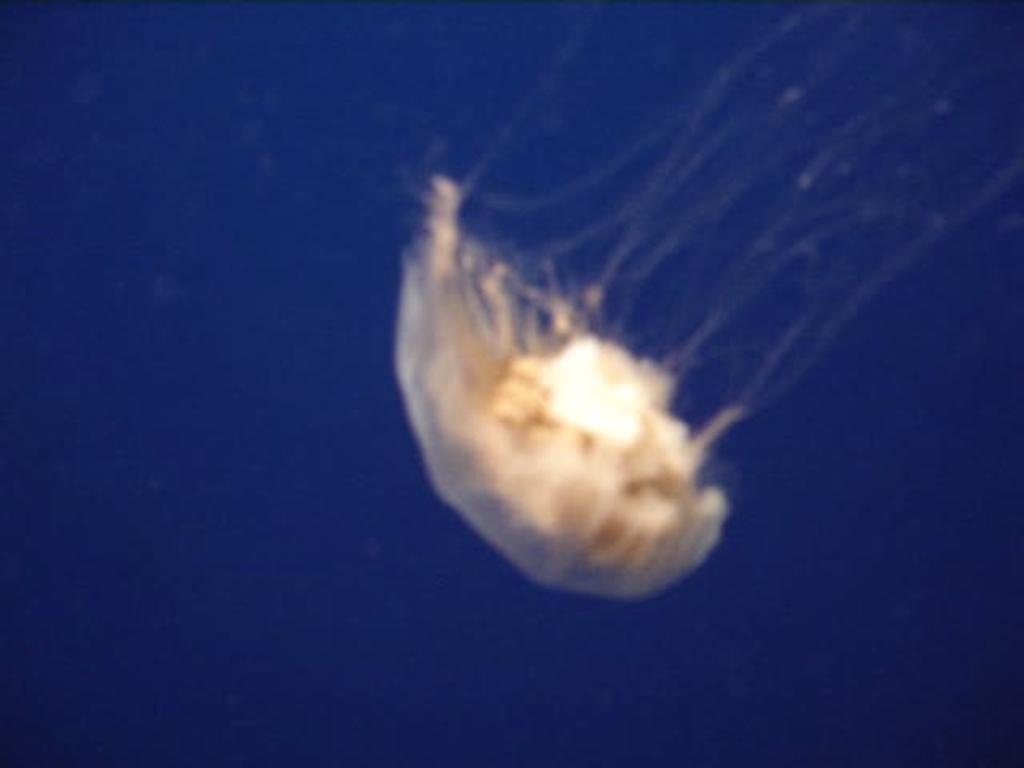How would you summarize this image in a sentence or two? In this image we can see a sky lantern. There is a clear and blue sky in the image. 